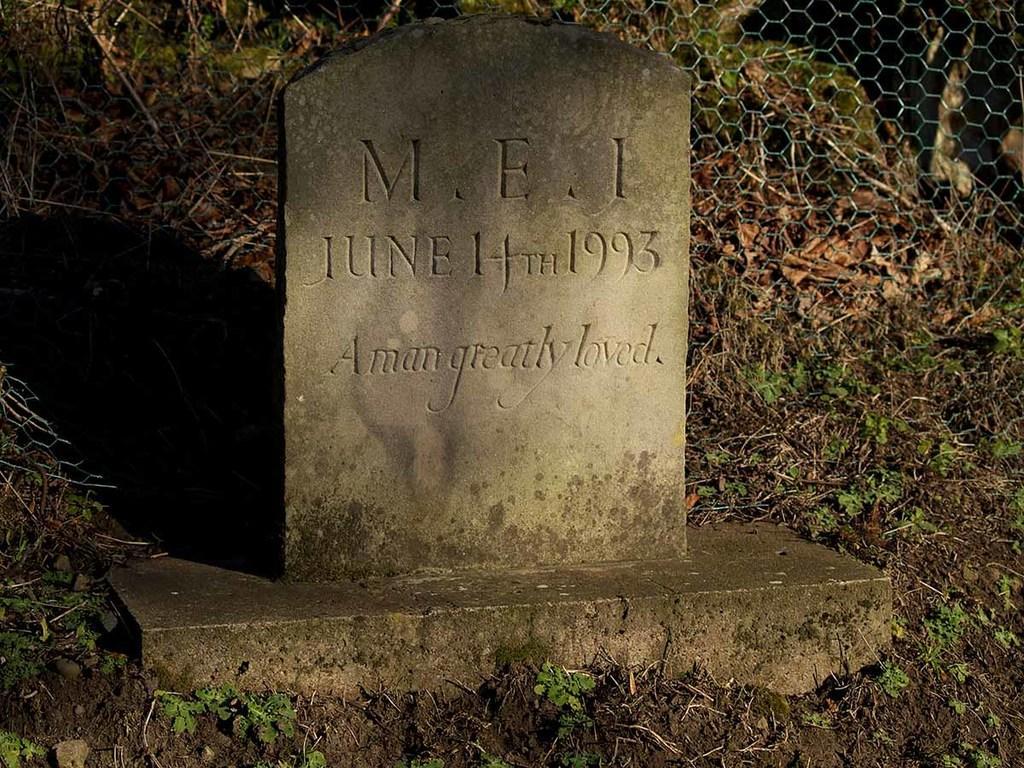Can you describe this image briefly? In this image we can see the headstone. And we can see the shadow of headstone. And we can see the soil. And we can see the grass. And in the background we can see the net fencing. 